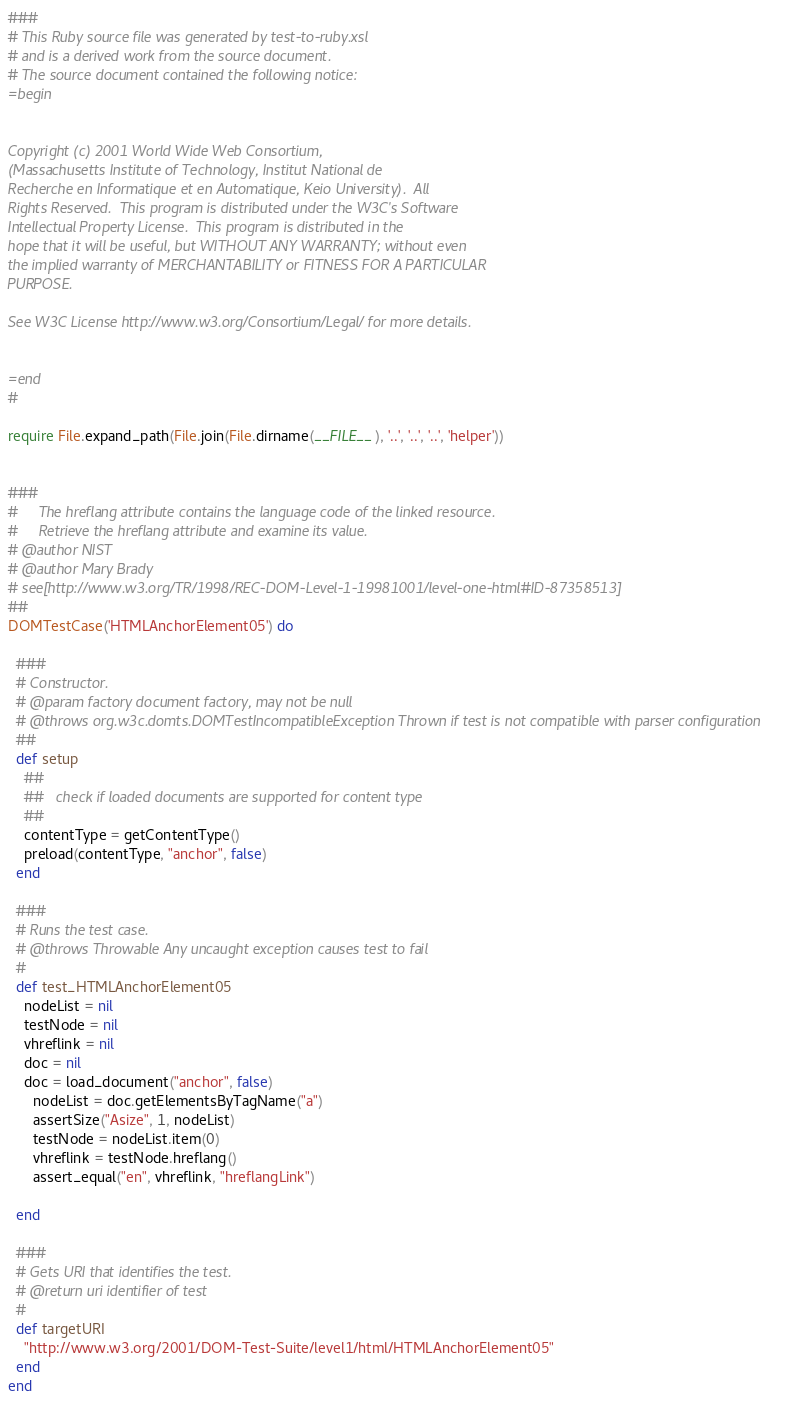<code> <loc_0><loc_0><loc_500><loc_500><_Ruby_>
###
# This Ruby source file was generated by test-to-ruby.xsl
# and is a derived work from the source document.
# The source document contained the following notice:
=begin


Copyright (c) 2001 World Wide Web Consortium, 
(Massachusetts Institute of Technology, Institut National de
Recherche en Informatique et en Automatique, Keio University).  All 
Rights Reserved.  This program is distributed under the W3C's Software
Intellectual Property License.  This program is distributed in the 
hope that it will be useful, but WITHOUT ANY WARRANTY; without even
the implied warranty of MERCHANTABILITY or FITNESS FOR A PARTICULAR 
PURPOSE.  

See W3C License http://www.w3.org/Consortium/Legal/ for more details.


=end
#

require File.expand_path(File.join(File.dirname(__FILE__), '..', '..', '..', 'helper'))


###
#     The hreflang attribute contains the language code of the linked resource. 
#     Retrieve the hreflang attribute and examine its value.  
# @author NIST
# @author Mary Brady
# see[http://www.w3.org/TR/1998/REC-DOM-Level-1-19981001/level-one-html#ID-87358513]
##
DOMTestCase('HTMLAnchorElement05') do

  ###
  # Constructor.
  # @param factory document factory, may not be null
  # @throws org.w3c.domts.DOMTestIncompatibleException Thrown if test is not compatible with parser configuration
  ##
  def setup
    ##
    ##   check if loaded documents are supported for content type
    ##
    contentType = getContentType()
    preload(contentType, "anchor", false)
  end

  ###
  # Runs the test case.
  # @throws Throwable Any uncaught exception causes test to fail
  #
  def test_HTMLAnchorElement05
    nodeList = nil
    testNode = nil
    vhreflink = nil
    doc = nil
    doc = load_document("anchor", false)
      nodeList = doc.getElementsByTagName("a")
      assertSize("Asize", 1, nodeList)
      testNode = nodeList.item(0)
      vhreflink = testNode.hreflang()
      assert_equal("en", vhreflink, "hreflangLink")
            
  end

  ###
  # Gets URI that identifies the test.
  # @return uri identifier of test
  #
  def targetURI
    "http://www.w3.org/2001/DOM-Test-Suite/level1/html/HTMLAnchorElement05"
  end
end

</code> 